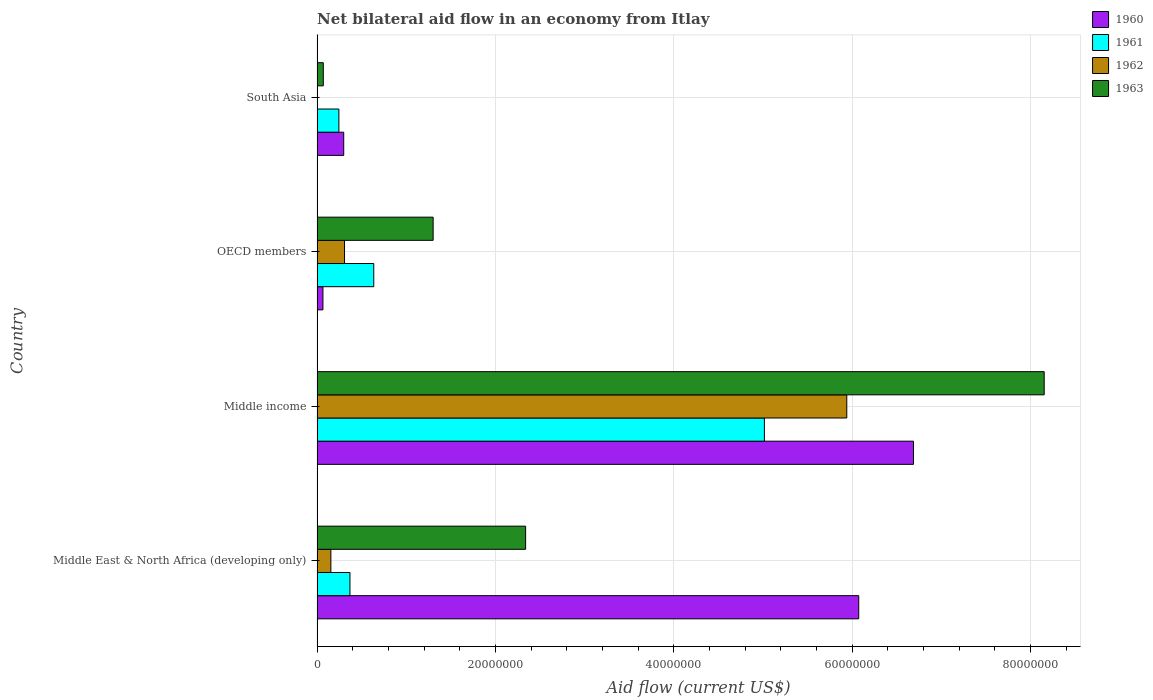How many bars are there on the 1st tick from the top?
Provide a succinct answer. 3. How many bars are there on the 3rd tick from the bottom?
Offer a terse response. 4. In how many cases, is the number of bars for a given country not equal to the number of legend labels?
Give a very brief answer. 1. What is the net bilateral aid flow in 1961 in South Asia?
Provide a short and direct response. 2.45e+06. Across all countries, what is the maximum net bilateral aid flow in 1963?
Provide a short and direct response. 8.16e+07. Across all countries, what is the minimum net bilateral aid flow in 1961?
Keep it short and to the point. 2.45e+06. In which country was the net bilateral aid flow in 1962 maximum?
Provide a short and direct response. Middle income. What is the total net bilateral aid flow in 1963 in the graph?
Keep it short and to the point. 1.19e+08. What is the difference between the net bilateral aid flow in 1960 in Middle income and that in South Asia?
Offer a very short reply. 6.39e+07. What is the difference between the net bilateral aid flow in 1962 in OECD members and the net bilateral aid flow in 1963 in Middle income?
Keep it short and to the point. -7.85e+07. What is the average net bilateral aid flow in 1960 per country?
Your answer should be compact. 3.28e+07. What is the difference between the net bilateral aid flow in 1963 and net bilateral aid flow in 1960 in Middle East & North Africa (developing only)?
Your response must be concise. -3.74e+07. What is the ratio of the net bilateral aid flow in 1963 in Middle East & North Africa (developing only) to that in South Asia?
Offer a very short reply. 33.41. Is the difference between the net bilateral aid flow in 1963 in Middle East & North Africa (developing only) and Middle income greater than the difference between the net bilateral aid flow in 1960 in Middle East & North Africa (developing only) and Middle income?
Your response must be concise. No. What is the difference between the highest and the second highest net bilateral aid flow in 1963?
Make the answer very short. 5.82e+07. What is the difference between the highest and the lowest net bilateral aid flow in 1960?
Ensure brevity in your answer.  6.62e+07. In how many countries, is the net bilateral aid flow in 1963 greater than the average net bilateral aid flow in 1963 taken over all countries?
Offer a terse response. 1. Is it the case that in every country, the sum of the net bilateral aid flow in 1961 and net bilateral aid flow in 1960 is greater than the sum of net bilateral aid flow in 1962 and net bilateral aid flow in 1963?
Offer a very short reply. No. Where does the legend appear in the graph?
Your response must be concise. Top right. How many legend labels are there?
Make the answer very short. 4. What is the title of the graph?
Give a very brief answer. Net bilateral aid flow in an economy from Itlay. Does "1973" appear as one of the legend labels in the graph?
Ensure brevity in your answer.  No. What is the label or title of the X-axis?
Provide a short and direct response. Aid flow (current US$). What is the Aid flow (current US$) of 1960 in Middle East & North Africa (developing only)?
Ensure brevity in your answer.  6.08e+07. What is the Aid flow (current US$) in 1961 in Middle East & North Africa (developing only)?
Offer a very short reply. 3.69e+06. What is the Aid flow (current US$) of 1962 in Middle East & North Africa (developing only)?
Offer a very short reply. 1.55e+06. What is the Aid flow (current US$) of 1963 in Middle East & North Africa (developing only)?
Offer a terse response. 2.34e+07. What is the Aid flow (current US$) of 1960 in Middle income?
Offer a very short reply. 6.69e+07. What is the Aid flow (current US$) in 1961 in Middle income?
Keep it short and to the point. 5.02e+07. What is the Aid flow (current US$) in 1962 in Middle income?
Keep it short and to the point. 5.94e+07. What is the Aid flow (current US$) of 1963 in Middle income?
Your response must be concise. 8.16e+07. What is the Aid flow (current US$) of 1960 in OECD members?
Your response must be concise. 6.60e+05. What is the Aid flow (current US$) of 1961 in OECD members?
Provide a succinct answer. 6.36e+06. What is the Aid flow (current US$) in 1962 in OECD members?
Provide a short and direct response. 3.08e+06. What is the Aid flow (current US$) in 1963 in OECD members?
Ensure brevity in your answer.  1.30e+07. What is the Aid flow (current US$) of 1960 in South Asia?
Make the answer very short. 2.99e+06. What is the Aid flow (current US$) of 1961 in South Asia?
Keep it short and to the point. 2.45e+06. What is the Aid flow (current US$) of 1962 in South Asia?
Offer a terse response. 0. What is the Aid flow (current US$) of 1963 in South Asia?
Offer a very short reply. 7.00e+05. Across all countries, what is the maximum Aid flow (current US$) in 1960?
Offer a terse response. 6.69e+07. Across all countries, what is the maximum Aid flow (current US$) of 1961?
Make the answer very short. 5.02e+07. Across all countries, what is the maximum Aid flow (current US$) in 1962?
Offer a very short reply. 5.94e+07. Across all countries, what is the maximum Aid flow (current US$) of 1963?
Ensure brevity in your answer.  8.16e+07. Across all countries, what is the minimum Aid flow (current US$) of 1960?
Keep it short and to the point. 6.60e+05. Across all countries, what is the minimum Aid flow (current US$) in 1961?
Your answer should be compact. 2.45e+06. Across all countries, what is the minimum Aid flow (current US$) in 1962?
Provide a succinct answer. 0. What is the total Aid flow (current US$) of 1960 in the graph?
Provide a succinct answer. 1.31e+08. What is the total Aid flow (current US$) in 1961 in the graph?
Make the answer very short. 6.27e+07. What is the total Aid flow (current US$) of 1962 in the graph?
Provide a short and direct response. 6.40e+07. What is the total Aid flow (current US$) in 1963 in the graph?
Offer a terse response. 1.19e+08. What is the difference between the Aid flow (current US$) of 1960 in Middle East & North Africa (developing only) and that in Middle income?
Your answer should be very brief. -6.14e+06. What is the difference between the Aid flow (current US$) in 1961 in Middle East & North Africa (developing only) and that in Middle income?
Your answer should be very brief. -4.65e+07. What is the difference between the Aid flow (current US$) of 1962 in Middle East & North Africa (developing only) and that in Middle income?
Your answer should be compact. -5.79e+07. What is the difference between the Aid flow (current US$) of 1963 in Middle East & North Africa (developing only) and that in Middle income?
Offer a very short reply. -5.82e+07. What is the difference between the Aid flow (current US$) of 1960 in Middle East & North Africa (developing only) and that in OECD members?
Keep it short and to the point. 6.01e+07. What is the difference between the Aid flow (current US$) in 1961 in Middle East & North Africa (developing only) and that in OECD members?
Keep it short and to the point. -2.67e+06. What is the difference between the Aid flow (current US$) in 1962 in Middle East & North Africa (developing only) and that in OECD members?
Provide a succinct answer. -1.53e+06. What is the difference between the Aid flow (current US$) of 1963 in Middle East & North Africa (developing only) and that in OECD members?
Make the answer very short. 1.04e+07. What is the difference between the Aid flow (current US$) in 1960 in Middle East & North Africa (developing only) and that in South Asia?
Your answer should be compact. 5.78e+07. What is the difference between the Aid flow (current US$) in 1961 in Middle East & North Africa (developing only) and that in South Asia?
Offer a very short reply. 1.24e+06. What is the difference between the Aid flow (current US$) of 1963 in Middle East & North Africa (developing only) and that in South Asia?
Ensure brevity in your answer.  2.27e+07. What is the difference between the Aid flow (current US$) of 1960 in Middle income and that in OECD members?
Give a very brief answer. 6.62e+07. What is the difference between the Aid flow (current US$) in 1961 in Middle income and that in OECD members?
Your response must be concise. 4.38e+07. What is the difference between the Aid flow (current US$) of 1962 in Middle income and that in OECD members?
Give a very brief answer. 5.63e+07. What is the difference between the Aid flow (current US$) in 1963 in Middle income and that in OECD members?
Offer a very short reply. 6.85e+07. What is the difference between the Aid flow (current US$) of 1960 in Middle income and that in South Asia?
Your response must be concise. 6.39e+07. What is the difference between the Aid flow (current US$) in 1961 in Middle income and that in South Asia?
Provide a succinct answer. 4.77e+07. What is the difference between the Aid flow (current US$) of 1963 in Middle income and that in South Asia?
Give a very brief answer. 8.08e+07. What is the difference between the Aid flow (current US$) of 1960 in OECD members and that in South Asia?
Ensure brevity in your answer.  -2.33e+06. What is the difference between the Aid flow (current US$) in 1961 in OECD members and that in South Asia?
Give a very brief answer. 3.91e+06. What is the difference between the Aid flow (current US$) in 1963 in OECD members and that in South Asia?
Your answer should be very brief. 1.23e+07. What is the difference between the Aid flow (current US$) of 1960 in Middle East & North Africa (developing only) and the Aid flow (current US$) of 1961 in Middle income?
Make the answer very short. 1.06e+07. What is the difference between the Aid flow (current US$) of 1960 in Middle East & North Africa (developing only) and the Aid flow (current US$) of 1962 in Middle income?
Ensure brevity in your answer.  1.34e+06. What is the difference between the Aid flow (current US$) in 1960 in Middle East & North Africa (developing only) and the Aid flow (current US$) in 1963 in Middle income?
Provide a succinct answer. -2.08e+07. What is the difference between the Aid flow (current US$) of 1961 in Middle East & North Africa (developing only) and the Aid flow (current US$) of 1962 in Middle income?
Keep it short and to the point. -5.57e+07. What is the difference between the Aid flow (current US$) of 1961 in Middle East & North Africa (developing only) and the Aid flow (current US$) of 1963 in Middle income?
Ensure brevity in your answer.  -7.79e+07. What is the difference between the Aid flow (current US$) in 1962 in Middle East & North Africa (developing only) and the Aid flow (current US$) in 1963 in Middle income?
Give a very brief answer. -8.00e+07. What is the difference between the Aid flow (current US$) of 1960 in Middle East & North Africa (developing only) and the Aid flow (current US$) of 1961 in OECD members?
Provide a succinct answer. 5.44e+07. What is the difference between the Aid flow (current US$) in 1960 in Middle East & North Africa (developing only) and the Aid flow (current US$) in 1962 in OECD members?
Offer a terse response. 5.77e+07. What is the difference between the Aid flow (current US$) of 1960 in Middle East & North Africa (developing only) and the Aid flow (current US$) of 1963 in OECD members?
Offer a very short reply. 4.77e+07. What is the difference between the Aid flow (current US$) in 1961 in Middle East & North Africa (developing only) and the Aid flow (current US$) in 1962 in OECD members?
Ensure brevity in your answer.  6.10e+05. What is the difference between the Aid flow (current US$) in 1961 in Middle East & North Africa (developing only) and the Aid flow (current US$) in 1963 in OECD members?
Your answer should be very brief. -9.33e+06. What is the difference between the Aid flow (current US$) of 1962 in Middle East & North Africa (developing only) and the Aid flow (current US$) of 1963 in OECD members?
Offer a terse response. -1.15e+07. What is the difference between the Aid flow (current US$) in 1960 in Middle East & North Africa (developing only) and the Aid flow (current US$) in 1961 in South Asia?
Provide a short and direct response. 5.83e+07. What is the difference between the Aid flow (current US$) of 1960 in Middle East & North Africa (developing only) and the Aid flow (current US$) of 1963 in South Asia?
Your response must be concise. 6.00e+07. What is the difference between the Aid flow (current US$) of 1961 in Middle East & North Africa (developing only) and the Aid flow (current US$) of 1963 in South Asia?
Your answer should be very brief. 2.99e+06. What is the difference between the Aid flow (current US$) in 1962 in Middle East & North Africa (developing only) and the Aid flow (current US$) in 1963 in South Asia?
Make the answer very short. 8.50e+05. What is the difference between the Aid flow (current US$) of 1960 in Middle income and the Aid flow (current US$) of 1961 in OECD members?
Make the answer very short. 6.05e+07. What is the difference between the Aid flow (current US$) of 1960 in Middle income and the Aid flow (current US$) of 1962 in OECD members?
Provide a succinct answer. 6.38e+07. What is the difference between the Aid flow (current US$) of 1960 in Middle income and the Aid flow (current US$) of 1963 in OECD members?
Ensure brevity in your answer.  5.39e+07. What is the difference between the Aid flow (current US$) of 1961 in Middle income and the Aid flow (current US$) of 1962 in OECD members?
Your answer should be compact. 4.71e+07. What is the difference between the Aid flow (current US$) of 1961 in Middle income and the Aid flow (current US$) of 1963 in OECD members?
Offer a terse response. 3.72e+07. What is the difference between the Aid flow (current US$) of 1962 in Middle income and the Aid flow (current US$) of 1963 in OECD members?
Make the answer very short. 4.64e+07. What is the difference between the Aid flow (current US$) of 1960 in Middle income and the Aid flow (current US$) of 1961 in South Asia?
Ensure brevity in your answer.  6.44e+07. What is the difference between the Aid flow (current US$) of 1960 in Middle income and the Aid flow (current US$) of 1963 in South Asia?
Your response must be concise. 6.62e+07. What is the difference between the Aid flow (current US$) in 1961 in Middle income and the Aid flow (current US$) in 1963 in South Asia?
Ensure brevity in your answer.  4.95e+07. What is the difference between the Aid flow (current US$) of 1962 in Middle income and the Aid flow (current US$) of 1963 in South Asia?
Your response must be concise. 5.87e+07. What is the difference between the Aid flow (current US$) of 1960 in OECD members and the Aid flow (current US$) of 1961 in South Asia?
Provide a succinct answer. -1.79e+06. What is the difference between the Aid flow (current US$) in 1961 in OECD members and the Aid flow (current US$) in 1963 in South Asia?
Your answer should be compact. 5.66e+06. What is the difference between the Aid flow (current US$) of 1962 in OECD members and the Aid flow (current US$) of 1963 in South Asia?
Your answer should be very brief. 2.38e+06. What is the average Aid flow (current US$) of 1960 per country?
Keep it short and to the point. 3.28e+07. What is the average Aid flow (current US$) of 1961 per country?
Provide a short and direct response. 1.57e+07. What is the average Aid flow (current US$) in 1962 per country?
Offer a very short reply. 1.60e+07. What is the average Aid flow (current US$) of 1963 per country?
Provide a succinct answer. 2.97e+07. What is the difference between the Aid flow (current US$) in 1960 and Aid flow (current US$) in 1961 in Middle East & North Africa (developing only)?
Give a very brief answer. 5.71e+07. What is the difference between the Aid flow (current US$) of 1960 and Aid flow (current US$) of 1962 in Middle East & North Africa (developing only)?
Provide a succinct answer. 5.92e+07. What is the difference between the Aid flow (current US$) of 1960 and Aid flow (current US$) of 1963 in Middle East & North Africa (developing only)?
Give a very brief answer. 3.74e+07. What is the difference between the Aid flow (current US$) in 1961 and Aid flow (current US$) in 1962 in Middle East & North Africa (developing only)?
Offer a very short reply. 2.14e+06. What is the difference between the Aid flow (current US$) of 1961 and Aid flow (current US$) of 1963 in Middle East & North Africa (developing only)?
Your answer should be very brief. -1.97e+07. What is the difference between the Aid flow (current US$) in 1962 and Aid flow (current US$) in 1963 in Middle East & North Africa (developing only)?
Your answer should be very brief. -2.18e+07. What is the difference between the Aid flow (current US$) of 1960 and Aid flow (current US$) of 1961 in Middle income?
Provide a short and direct response. 1.67e+07. What is the difference between the Aid flow (current US$) in 1960 and Aid flow (current US$) in 1962 in Middle income?
Give a very brief answer. 7.48e+06. What is the difference between the Aid flow (current US$) of 1960 and Aid flow (current US$) of 1963 in Middle income?
Your answer should be compact. -1.47e+07. What is the difference between the Aid flow (current US$) of 1961 and Aid flow (current US$) of 1962 in Middle income?
Your response must be concise. -9.24e+06. What is the difference between the Aid flow (current US$) in 1961 and Aid flow (current US$) in 1963 in Middle income?
Provide a succinct answer. -3.14e+07. What is the difference between the Aid flow (current US$) in 1962 and Aid flow (current US$) in 1963 in Middle income?
Your answer should be compact. -2.21e+07. What is the difference between the Aid flow (current US$) of 1960 and Aid flow (current US$) of 1961 in OECD members?
Make the answer very short. -5.70e+06. What is the difference between the Aid flow (current US$) in 1960 and Aid flow (current US$) in 1962 in OECD members?
Make the answer very short. -2.42e+06. What is the difference between the Aid flow (current US$) in 1960 and Aid flow (current US$) in 1963 in OECD members?
Your answer should be very brief. -1.24e+07. What is the difference between the Aid flow (current US$) of 1961 and Aid flow (current US$) of 1962 in OECD members?
Provide a short and direct response. 3.28e+06. What is the difference between the Aid flow (current US$) of 1961 and Aid flow (current US$) of 1963 in OECD members?
Provide a succinct answer. -6.66e+06. What is the difference between the Aid flow (current US$) of 1962 and Aid flow (current US$) of 1963 in OECD members?
Your answer should be very brief. -9.94e+06. What is the difference between the Aid flow (current US$) of 1960 and Aid flow (current US$) of 1961 in South Asia?
Offer a very short reply. 5.40e+05. What is the difference between the Aid flow (current US$) of 1960 and Aid flow (current US$) of 1963 in South Asia?
Your answer should be very brief. 2.29e+06. What is the difference between the Aid flow (current US$) in 1961 and Aid flow (current US$) in 1963 in South Asia?
Offer a terse response. 1.75e+06. What is the ratio of the Aid flow (current US$) of 1960 in Middle East & North Africa (developing only) to that in Middle income?
Provide a short and direct response. 0.91. What is the ratio of the Aid flow (current US$) of 1961 in Middle East & North Africa (developing only) to that in Middle income?
Provide a short and direct response. 0.07. What is the ratio of the Aid flow (current US$) of 1962 in Middle East & North Africa (developing only) to that in Middle income?
Your answer should be very brief. 0.03. What is the ratio of the Aid flow (current US$) of 1963 in Middle East & North Africa (developing only) to that in Middle income?
Your answer should be very brief. 0.29. What is the ratio of the Aid flow (current US$) of 1960 in Middle East & North Africa (developing only) to that in OECD members?
Provide a succinct answer. 92.05. What is the ratio of the Aid flow (current US$) of 1961 in Middle East & North Africa (developing only) to that in OECD members?
Give a very brief answer. 0.58. What is the ratio of the Aid flow (current US$) of 1962 in Middle East & North Africa (developing only) to that in OECD members?
Your response must be concise. 0.5. What is the ratio of the Aid flow (current US$) in 1963 in Middle East & North Africa (developing only) to that in OECD members?
Offer a very short reply. 1.8. What is the ratio of the Aid flow (current US$) of 1960 in Middle East & North Africa (developing only) to that in South Asia?
Provide a short and direct response. 20.32. What is the ratio of the Aid flow (current US$) in 1961 in Middle East & North Africa (developing only) to that in South Asia?
Provide a succinct answer. 1.51. What is the ratio of the Aid flow (current US$) in 1963 in Middle East & North Africa (developing only) to that in South Asia?
Your response must be concise. 33.41. What is the ratio of the Aid flow (current US$) of 1960 in Middle income to that in OECD members?
Provide a succinct answer. 101.35. What is the ratio of the Aid flow (current US$) of 1961 in Middle income to that in OECD members?
Provide a short and direct response. 7.89. What is the ratio of the Aid flow (current US$) of 1962 in Middle income to that in OECD members?
Provide a succinct answer. 19.29. What is the ratio of the Aid flow (current US$) of 1963 in Middle income to that in OECD members?
Make the answer very short. 6.26. What is the ratio of the Aid flow (current US$) of 1960 in Middle income to that in South Asia?
Keep it short and to the point. 22.37. What is the ratio of the Aid flow (current US$) of 1961 in Middle income to that in South Asia?
Offer a very short reply. 20.48. What is the ratio of the Aid flow (current US$) in 1963 in Middle income to that in South Asia?
Your answer should be compact. 116.5. What is the ratio of the Aid flow (current US$) of 1960 in OECD members to that in South Asia?
Your answer should be compact. 0.22. What is the ratio of the Aid flow (current US$) of 1961 in OECD members to that in South Asia?
Give a very brief answer. 2.6. What is the difference between the highest and the second highest Aid flow (current US$) in 1960?
Ensure brevity in your answer.  6.14e+06. What is the difference between the highest and the second highest Aid flow (current US$) in 1961?
Offer a very short reply. 4.38e+07. What is the difference between the highest and the second highest Aid flow (current US$) in 1962?
Offer a very short reply. 5.63e+07. What is the difference between the highest and the second highest Aid flow (current US$) of 1963?
Give a very brief answer. 5.82e+07. What is the difference between the highest and the lowest Aid flow (current US$) of 1960?
Ensure brevity in your answer.  6.62e+07. What is the difference between the highest and the lowest Aid flow (current US$) of 1961?
Keep it short and to the point. 4.77e+07. What is the difference between the highest and the lowest Aid flow (current US$) of 1962?
Provide a succinct answer. 5.94e+07. What is the difference between the highest and the lowest Aid flow (current US$) in 1963?
Keep it short and to the point. 8.08e+07. 